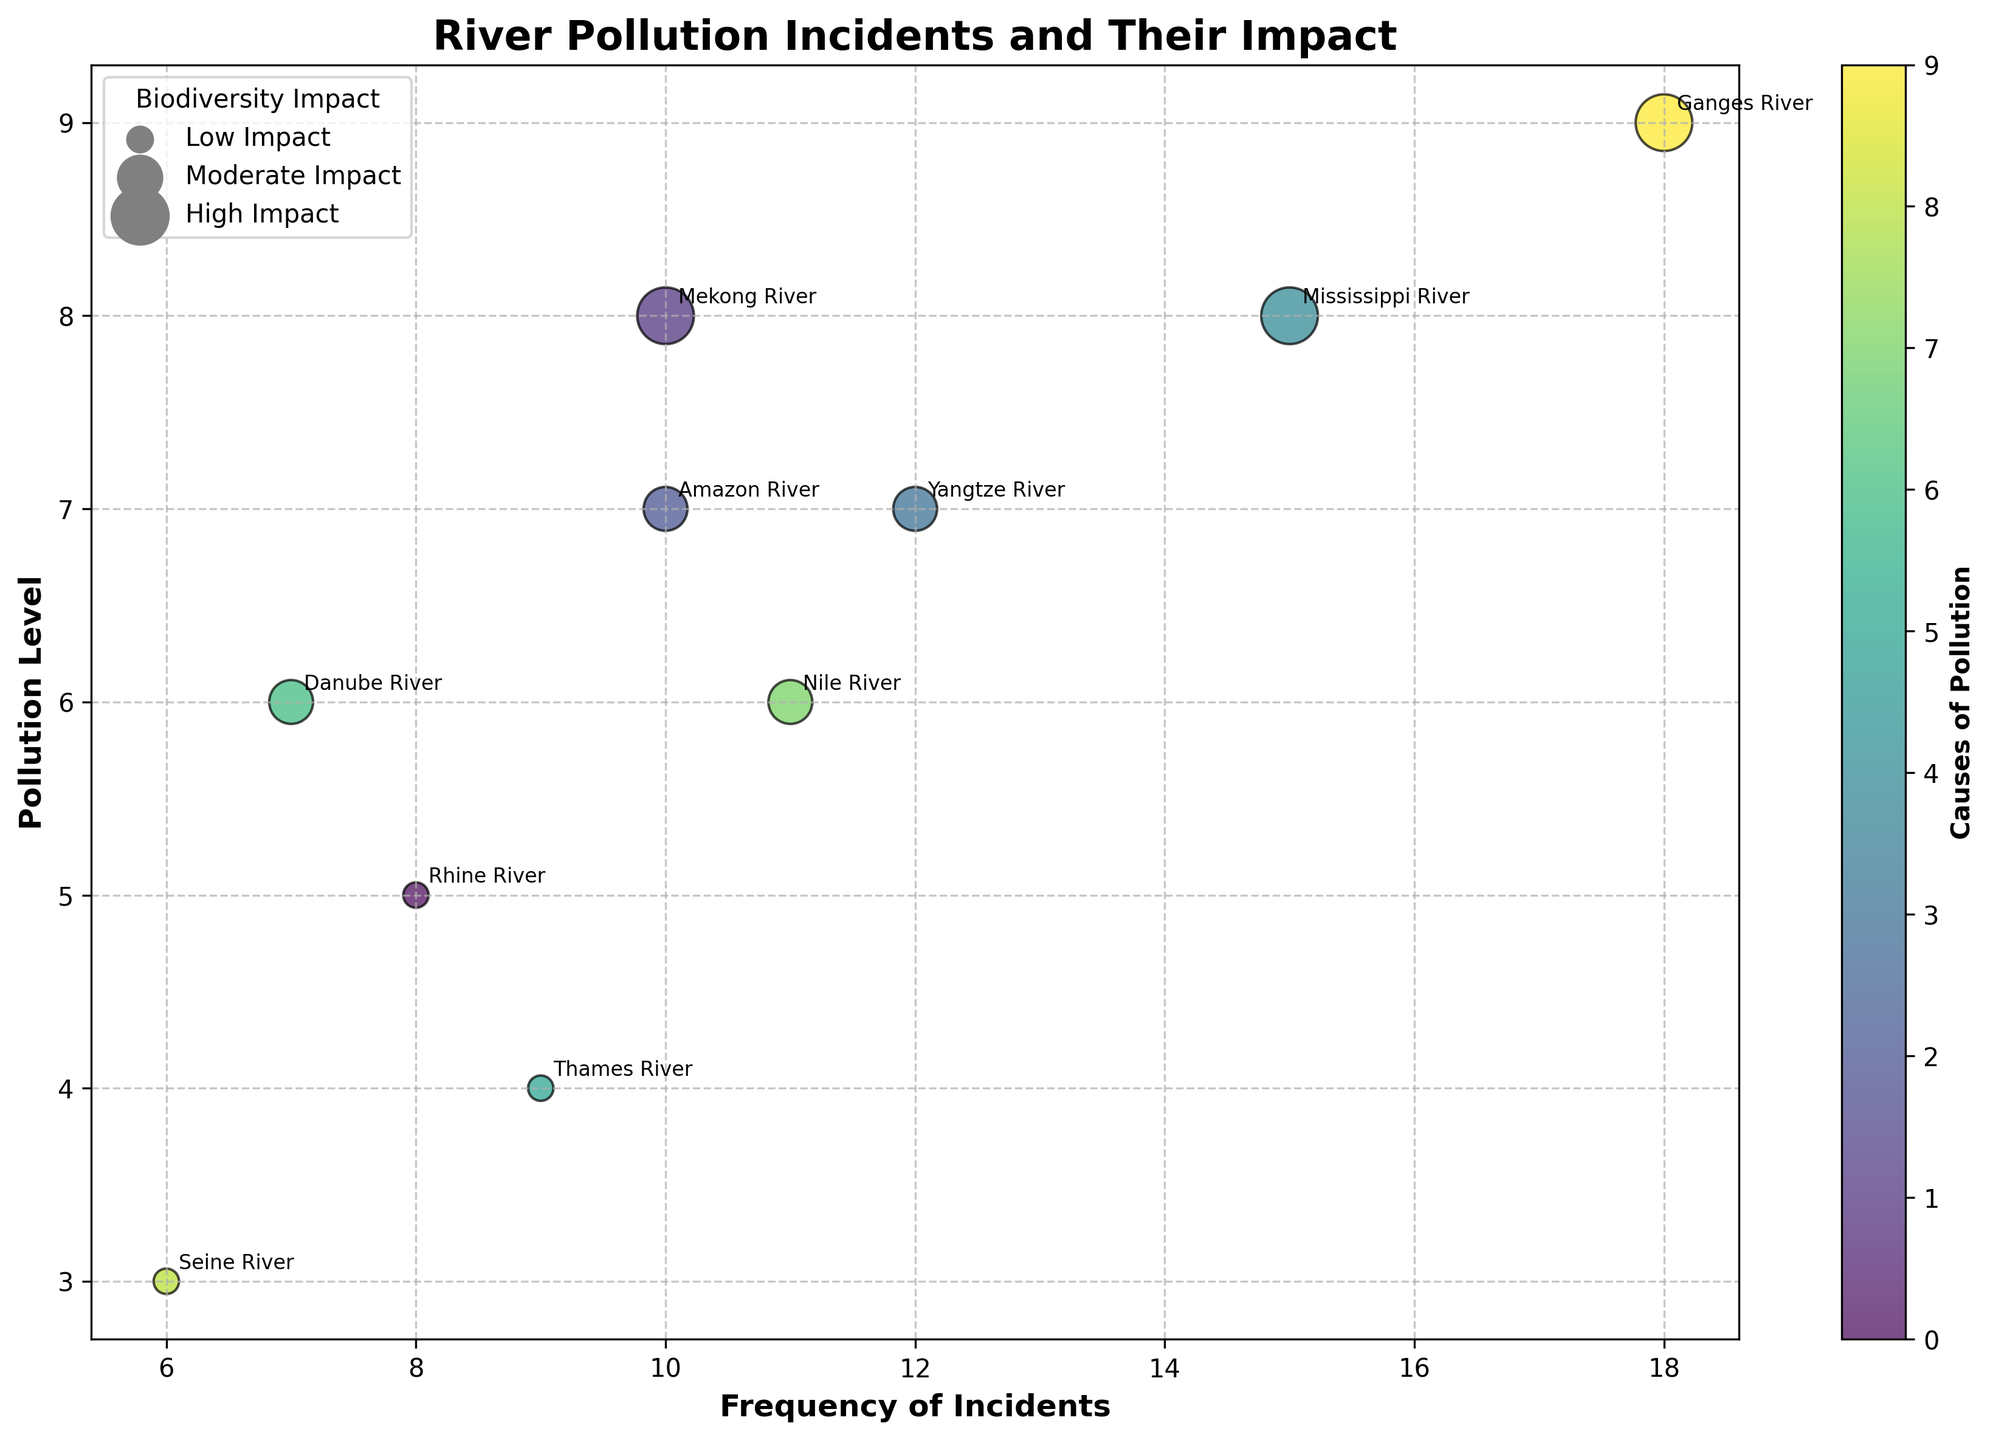What's the title of the figure? The title is located at the top center of the figure, usually in a larger and bold font for visibility. In this case, the title is "River Pollution Incidents and Their Impact".
Answer: River Pollution Incidents and Their Impact Which river experienced the highest pollution level? To determine which river has the highest pollution level, look at the y-axis for the highest value. The highest y-axis value corresponds to the Ganges River with a pollution level of 9.
Answer: Ganges River What does the size of the bubbles represent? In the legend located at the upper left, it states that the size of the bubbles represents the biodiversity impact, categorized as Low, Moderate, and High.
Answer: Biodiversity impact Which river has the lowest frequency of incidents and what is the pollution level for it? Look for the smallest x-axis value to identify the river with the lowest frequency of incidents, which is the Seine River with a frequency of 6 and a pollution level of 3.
Answer: Seine River, pollution level 3 Which cause of pollution has the most incidents? Inspecting the x-axis values and corresponding colors, the Ganges River has an incidence frequency of 18, the highest. Its cause of pollution is Urban Sewage.
Answer: Urban Sewage Compare the frequency and pollution level of the Amazon River and Yangtze River. The Amazon River has a frequency of 10 and a pollution level of 7. The Yangtze River has a frequency of 12 and a pollution level of 7. Both have the same pollution level, but Yangtze River has a higher frequency.
Answer: Amazon (Frequency: 10, Pollution: 7), Yangtze (Frequency: 12, Pollution: 7) What's the relationship between pollution level and biodiversity impact for rivers with high impact? Identify high impact bubbles (largest size bubbles). They correspond to the Ganges River, Mississippi River, and Mekong River, with pollution levels of 9, 8, and 8, respectively. High impact is correlated with higher pollution levels among these rivers.
Answer: Higher pollution levels correlate with high biodiversity impact What is the average pollution level of the industrial waste cause? The industrial waste cause affects the Mississippi River and Yangtze River with pollution levels of 8 and 7. The average is calculated by (8 + 7) / 2 = 7.5.
Answer: 7.5 Identify a river with a moderate biodiversity impact and provide its corresponding pollution level and frequency. Identifying moderate impact bubbles (medium size bubbles), we look at the Amazon River having a pollution level of 7 and a frequency of 10.
Answer: Amazon River, pollution level 7, frequency 10 